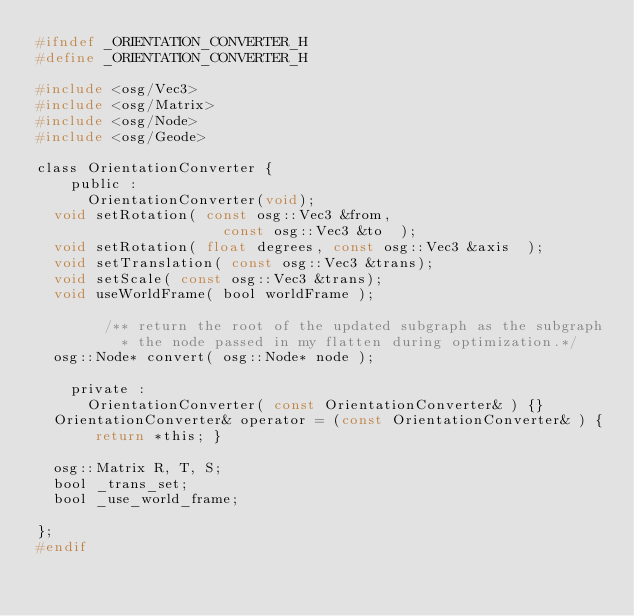<code> <loc_0><loc_0><loc_500><loc_500><_C_>#ifndef _ORIENTATION_CONVERTER_H
#define _ORIENTATION_CONVERTER_H

#include <osg/Vec3>
#include <osg/Matrix>
#include <osg/Node>
#include <osg/Geode>

class OrientationConverter {
    public :
    	OrientationConverter(void);
	void setRotation( const osg::Vec3 &from, 
	                    const osg::Vec3 &to  );
	void setRotation( float degrees, const osg::Vec3 &axis  );
	void setTranslation( const osg::Vec3 &trans);
	void setScale( const osg::Vec3 &trans);
	void useWorldFrame( bool worldFrame );
        
        /** return the root of the updated subgraph as the subgraph
          * the node passed in my flatten during optimization.*/
	osg::Node* convert( osg::Node* node );

    private :
    	OrientationConverter( const OrientationConverter& ) {}
	OrientationConverter& operator = (const OrientationConverter& ) { return *this; }

	osg::Matrix R, T, S;
	bool _trans_set;
	bool _use_world_frame;

};
#endif
</code> 